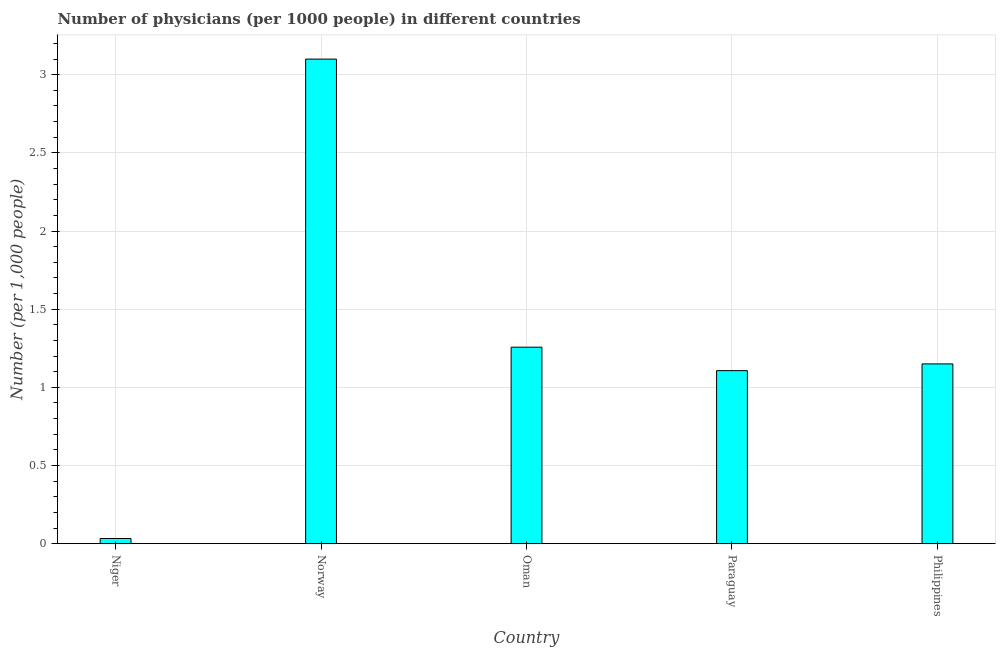Does the graph contain grids?
Give a very brief answer. Yes. What is the title of the graph?
Keep it short and to the point. Number of physicians (per 1000 people) in different countries. What is the label or title of the Y-axis?
Provide a succinct answer. Number (per 1,0 people). What is the number of physicians in Paraguay?
Your answer should be very brief. 1.11. Across all countries, what is the maximum number of physicians?
Make the answer very short. 3.1. Across all countries, what is the minimum number of physicians?
Keep it short and to the point. 0.03. In which country was the number of physicians maximum?
Keep it short and to the point. Norway. In which country was the number of physicians minimum?
Give a very brief answer. Niger. What is the sum of the number of physicians?
Offer a very short reply. 6.65. What is the difference between the number of physicians in Norway and Philippines?
Provide a short and direct response. 1.95. What is the average number of physicians per country?
Offer a very short reply. 1.33. What is the median number of physicians?
Keep it short and to the point. 1.15. What is the ratio of the number of physicians in Niger to that in Oman?
Keep it short and to the point. 0.03. What is the difference between the highest and the second highest number of physicians?
Your answer should be compact. 1.84. Is the sum of the number of physicians in Norway and Oman greater than the maximum number of physicians across all countries?
Provide a short and direct response. Yes. What is the difference between the highest and the lowest number of physicians?
Your answer should be compact. 3.07. In how many countries, is the number of physicians greater than the average number of physicians taken over all countries?
Keep it short and to the point. 1. Are all the bars in the graph horizontal?
Keep it short and to the point. No. How many countries are there in the graph?
Your answer should be compact. 5. What is the difference between two consecutive major ticks on the Y-axis?
Your answer should be very brief. 0.5. Are the values on the major ticks of Y-axis written in scientific E-notation?
Your response must be concise. No. What is the Number (per 1,000 people) in Niger?
Your answer should be compact. 0.03. What is the Number (per 1,000 people) of Norway?
Make the answer very short. 3.1. What is the Number (per 1,000 people) of Oman?
Offer a terse response. 1.26. What is the Number (per 1,000 people) in Paraguay?
Your answer should be very brief. 1.11. What is the Number (per 1,000 people) of Philippines?
Keep it short and to the point. 1.15. What is the difference between the Number (per 1,000 people) in Niger and Norway?
Your answer should be very brief. -3.07. What is the difference between the Number (per 1,000 people) in Niger and Oman?
Ensure brevity in your answer.  -1.22. What is the difference between the Number (per 1,000 people) in Niger and Paraguay?
Your answer should be very brief. -1.07. What is the difference between the Number (per 1,000 people) in Niger and Philippines?
Give a very brief answer. -1.12. What is the difference between the Number (per 1,000 people) in Norway and Oman?
Offer a terse response. 1.84. What is the difference between the Number (per 1,000 people) in Norway and Paraguay?
Your answer should be very brief. 1.99. What is the difference between the Number (per 1,000 people) in Norway and Philippines?
Your answer should be compact. 1.95. What is the difference between the Number (per 1,000 people) in Oman and Philippines?
Provide a succinct answer. 0.11. What is the difference between the Number (per 1,000 people) in Paraguay and Philippines?
Your response must be concise. -0.04. What is the ratio of the Number (per 1,000 people) in Niger to that in Norway?
Provide a succinct answer. 0.01. What is the ratio of the Number (per 1,000 people) in Niger to that in Oman?
Offer a very short reply. 0.03. What is the ratio of the Number (per 1,000 people) in Niger to that in Paraguay?
Give a very brief answer. 0.03. What is the ratio of the Number (per 1,000 people) in Niger to that in Philippines?
Keep it short and to the point. 0.03. What is the ratio of the Number (per 1,000 people) in Norway to that in Oman?
Offer a terse response. 2.47. What is the ratio of the Number (per 1,000 people) in Norway to that in Philippines?
Provide a succinct answer. 2.7. What is the ratio of the Number (per 1,000 people) in Oman to that in Paraguay?
Your answer should be very brief. 1.14. What is the ratio of the Number (per 1,000 people) in Oman to that in Philippines?
Your answer should be compact. 1.09. 